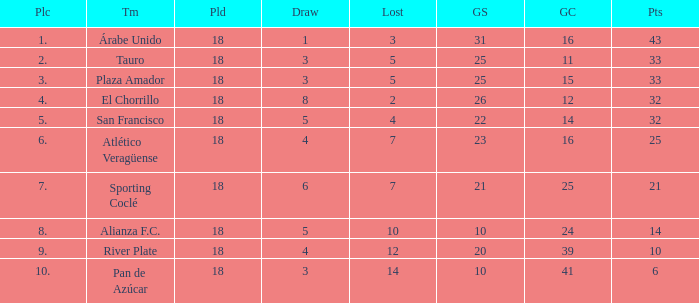How many goals were conceded by the team with more than 21 points more than 5 draws and less than 18 games played? None. 